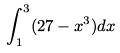<formula> <loc_0><loc_0><loc_500><loc_500>\int _ { 1 } ^ { 3 } ( 2 7 - x ^ { 3 } ) d x</formula> 